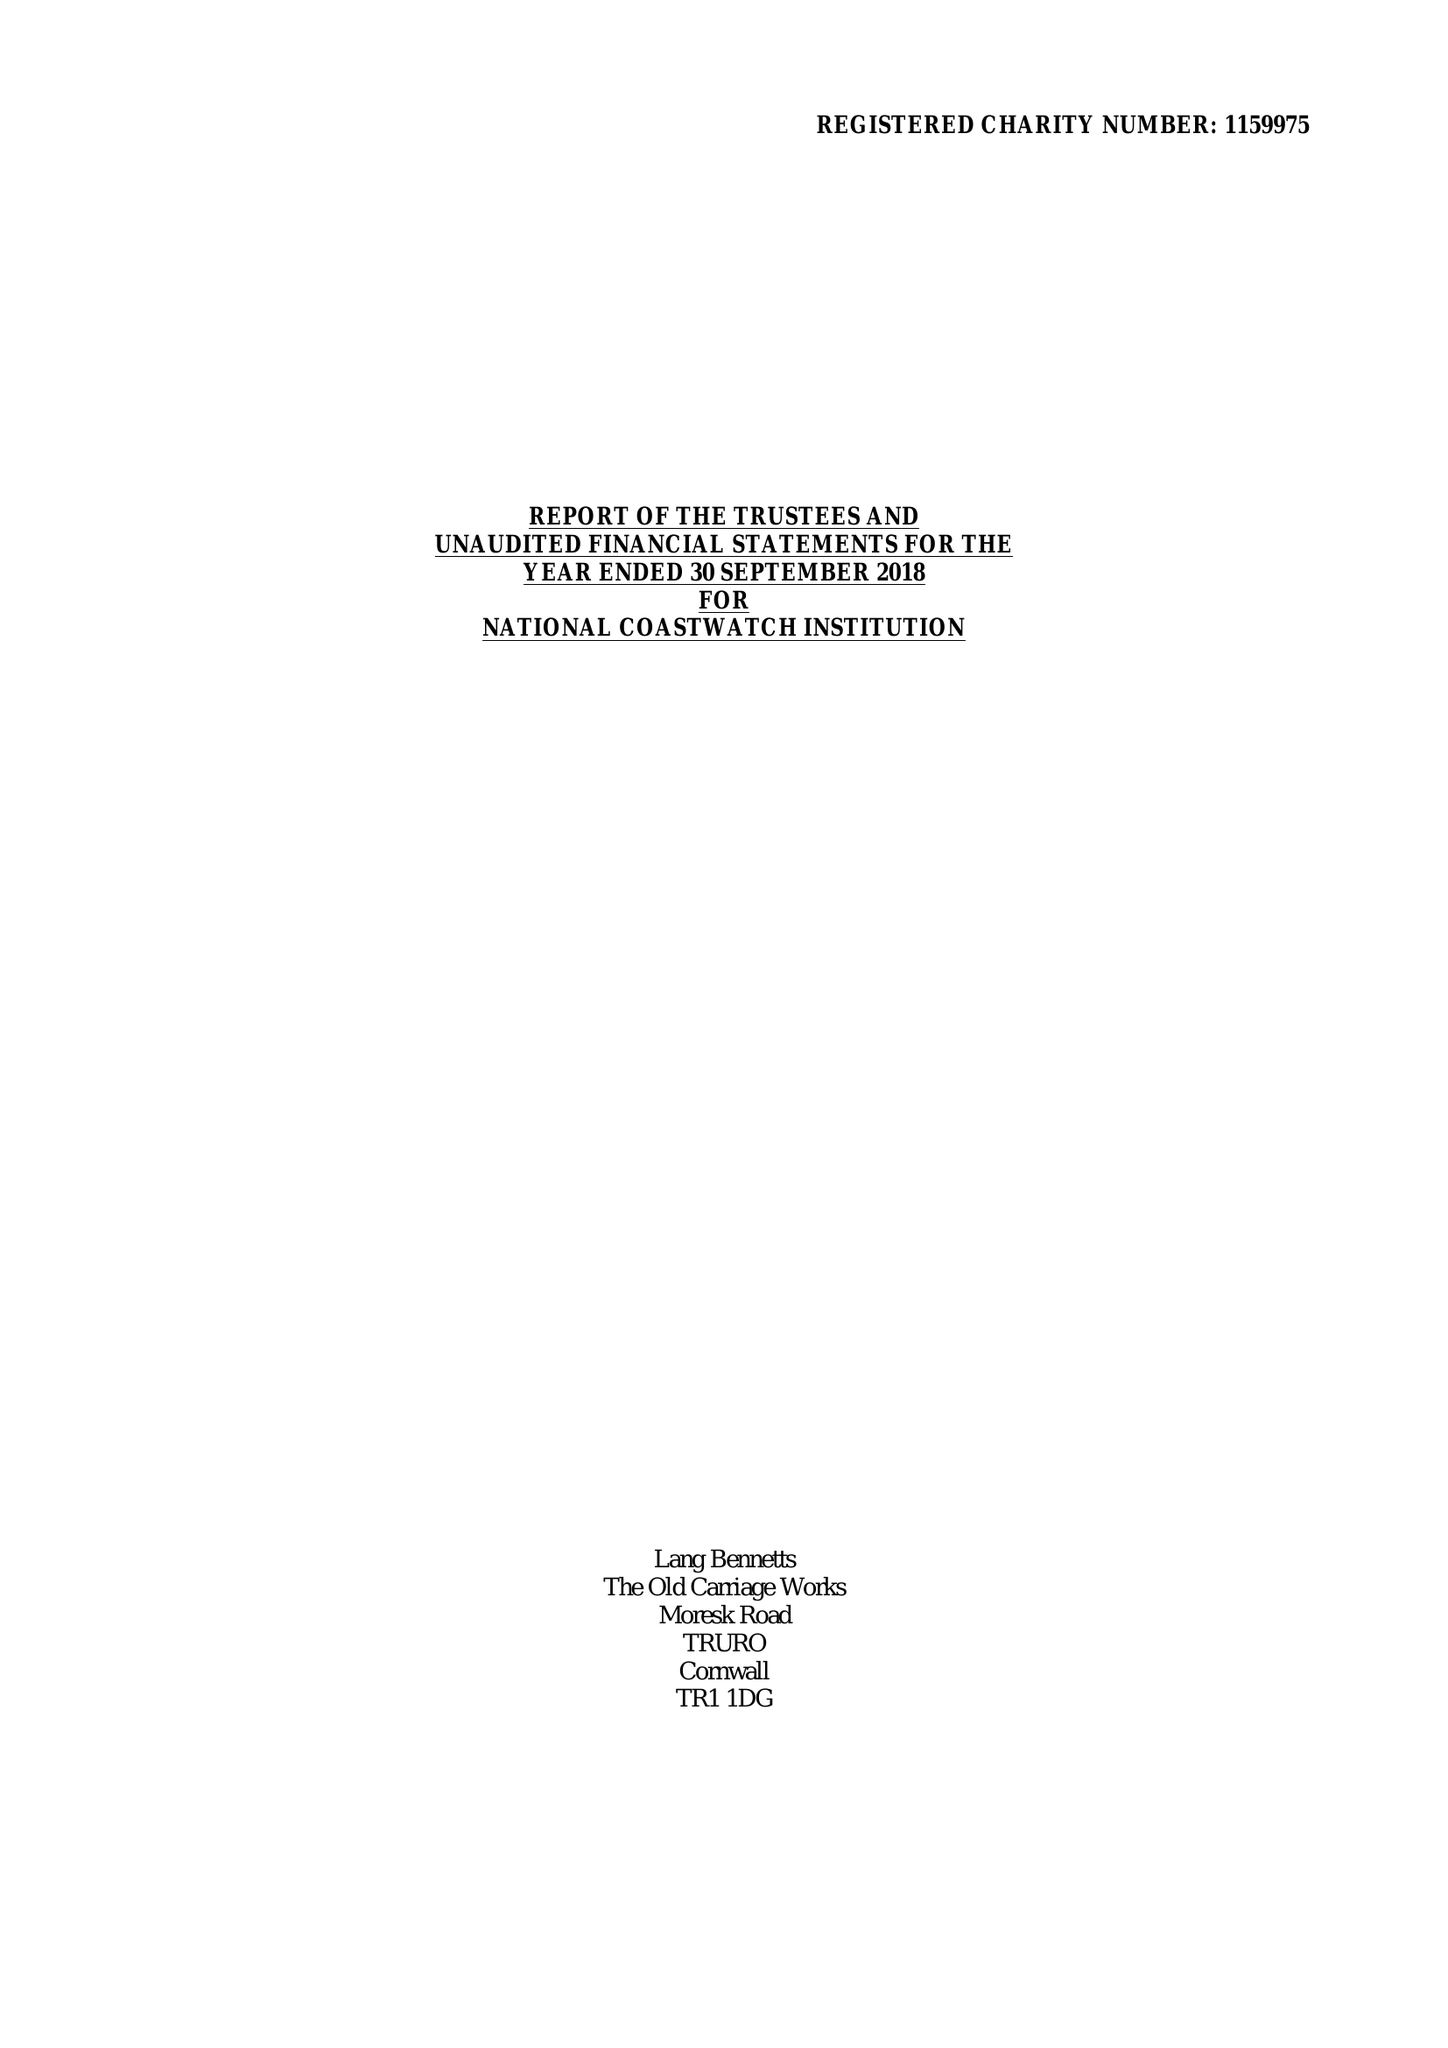What is the value for the address__postcode?
Answer the question using a single word or phrase. PL14 4AB 